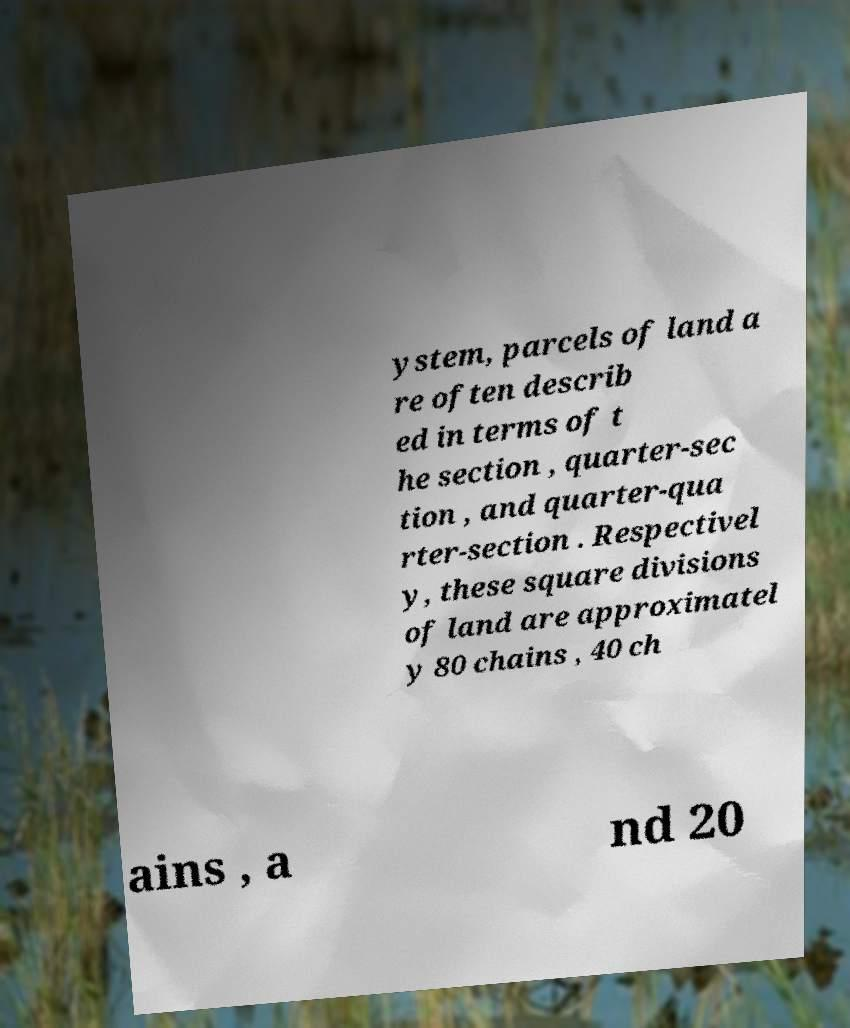Can you read and provide the text displayed in the image?This photo seems to have some interesting text. Can you extract and type it out for me? ystem, parcels of land a re often describ ed in terms of t he section , quarter-sec tion , and quarter-qua rter-section . Respectivel y, these square divisions of land are approximatel y 80 chains , 40 ch ains , a nd 20 